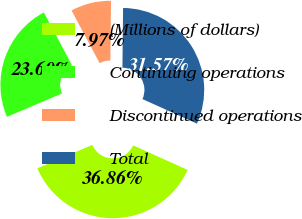Convert chart to OTSL. <chart><loc_0><loc_0><loc_500><loc_500><pie_chart><fcel>(Millions of dollars)<fcel>Continuing operations<fcel>Discontinued operations<fcel>Total<nl><fcel>36.86%<fcel>23.6%<fcel>7.97%<fcel>31.57%<nl></chart> 